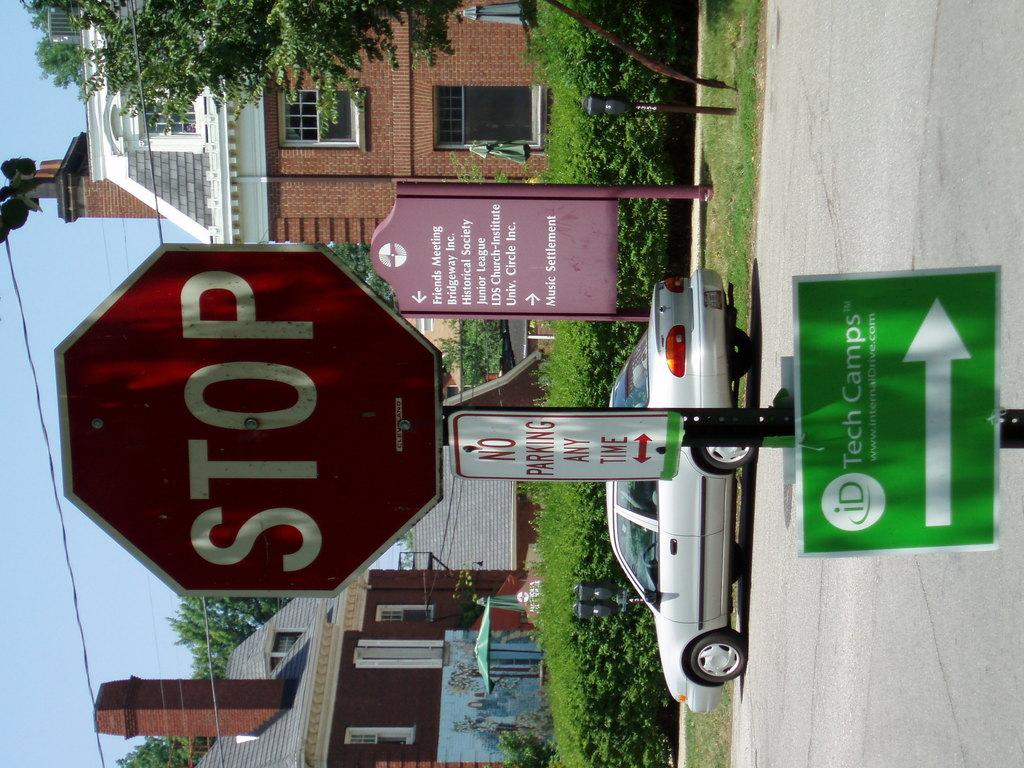<image>
Render a clear and concise summary of the photo. A stop sign with a sign for tech camps under it. 